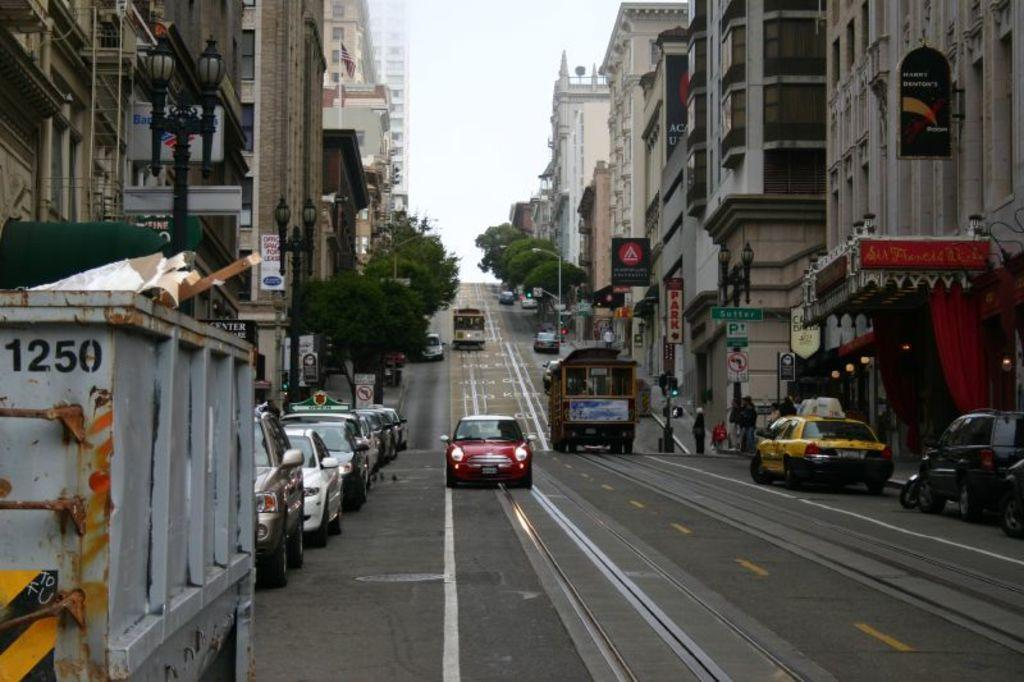Provide a one-sentence caption for the provided image. A red cars is driving up the street and is approaching dumpster 1250. 